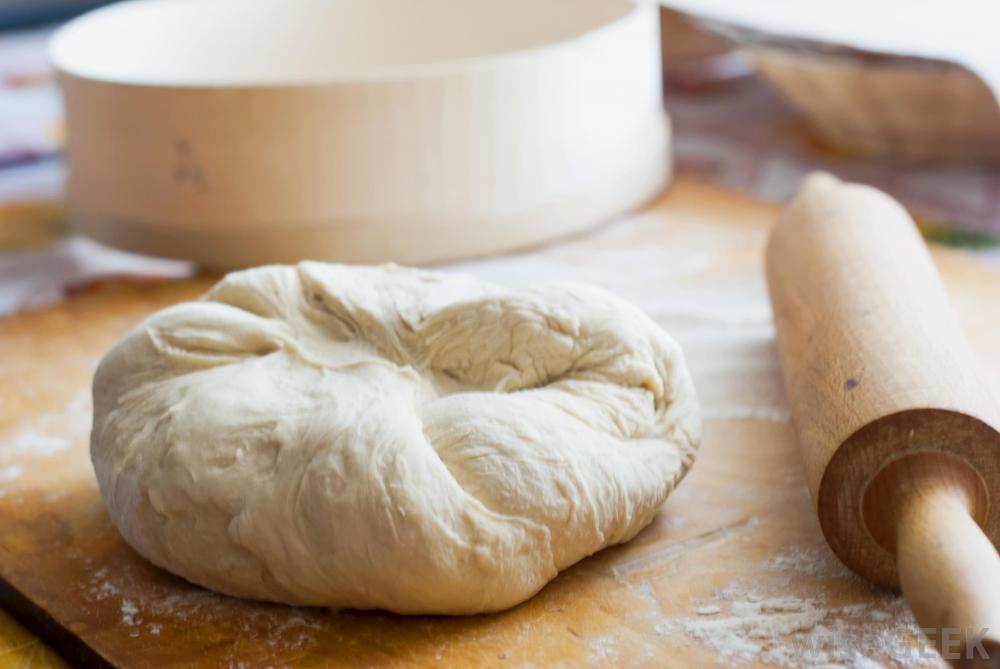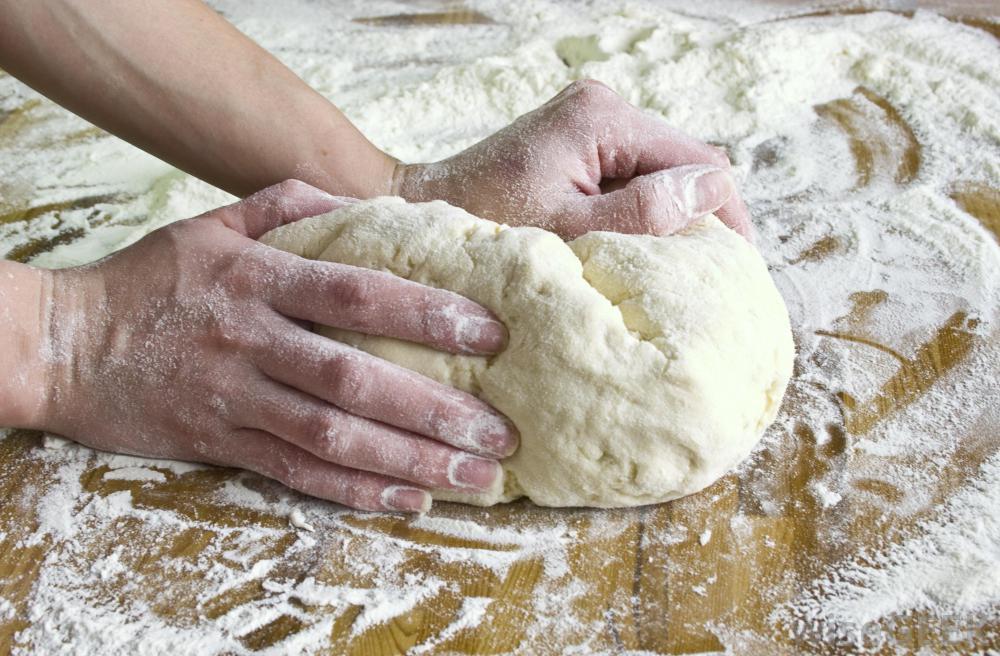The first image is the image on the left, the second image is the image on the right. For the images displayed, is the sentence "One of the images shows a pair of hands kneading dough and the other image shows a ball of dough in a bowl." factually correct? Answer yes or no. No. The first image is the image on the left, the second image is the image on the right. For the images displayed, is the sentence "Exactly one ball of dough is on a table." factually correct? Answer yes or no. No. 